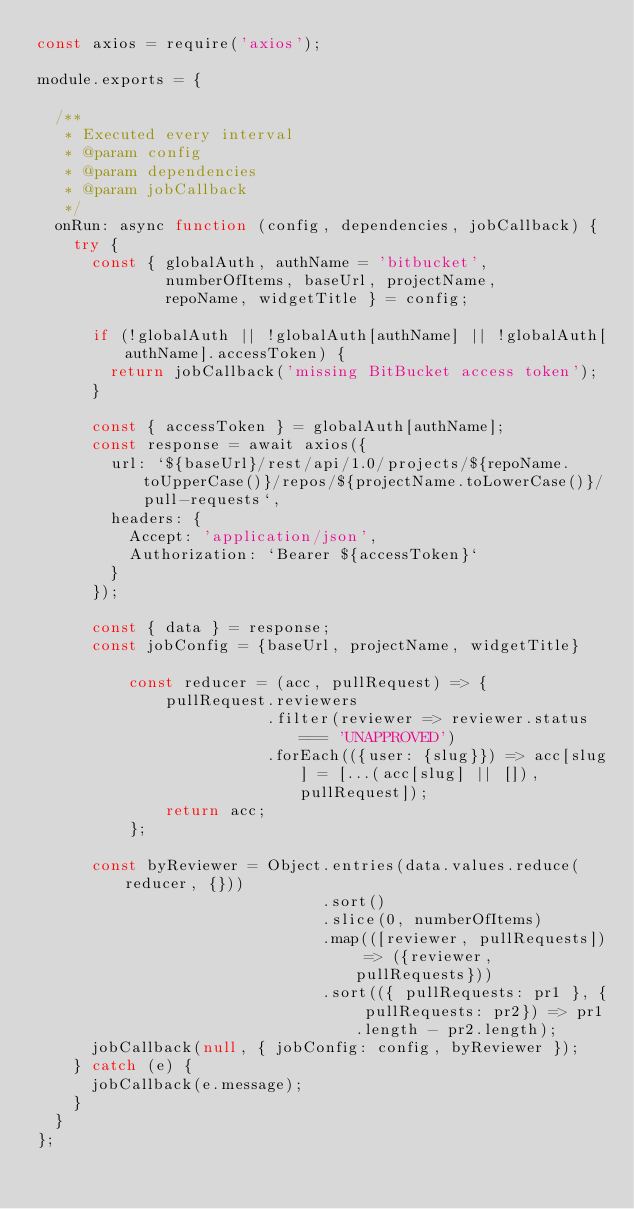Convert code to text. <code><loc_0><loc_0><loc_500><loc_500><_JavaScript_>const axios = require('axios');

module.exports = {

	/**
	 * Executed every interval
	 * @param config
	 * @param dependencies
	 * @param jobCallback
	 */
	onRun: async function (config, dependencies, jobCallback) {
		try {
			const { globalAuth, authName = 'bitbucket',
			        numberOfItems, baseUrl, projectName,
			        repoName, widgetTitle } = config;

			if (!globalAuth || !globalAuth[authName] || !globalAuth[authName].accessToken) {
				return jobCallback('missing BitBucket access token');
			}

			const { accessToken } = globalAuth[authName];
			const response = await axios({
				url: `${baseUrl}/rest/api/1.0/projects/${repoName.toUpperCase()}/repos/${projectName.toLowerCase()}/pull-requests`,
				headers: {
					Accept: 'application/json',
					Authorization: `Bearer ${accessToken}`
				}
			});

			const { data } = response;
			const jobConfig = {baseUrl, projectName, widgetTitle}

	        const reducer = (acc, pullRequest) => {
	            pullRequest.reviewers
	                       .filter(reviewer => reviewer.status === 'UNAPPROVED')
	                       .forEach(({user: {slug}}) => acc[slug] = [...(acc[slug] || []), pullRequest]);
	            return acc;
	        };

			const byReviewer = Object.entries(data.values.reduce(reducer, {}))
			                         .sort()
			                         .slice(0, numberOfItems)
			                         .map(([reviewer, pullRequests]) => ({reviewer, pullRequests}))
			                         .sort(({ pullRequests: pr1 }, { pullRequests: pr2}) => pr1.length - pr2.length);
			jobCallback(null, { jobConfig: config, byReviewer });
		} catch (e) {
			jobCallback(e.message);
		}
	}
};
</code> 